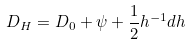<formula> <loc_0><loc_0><loc_500><loc_500>D _ { H } = D _ { 0 } + \psi + \frac { 1 } { 2 } h ^ { - 1 } d h</formula> 